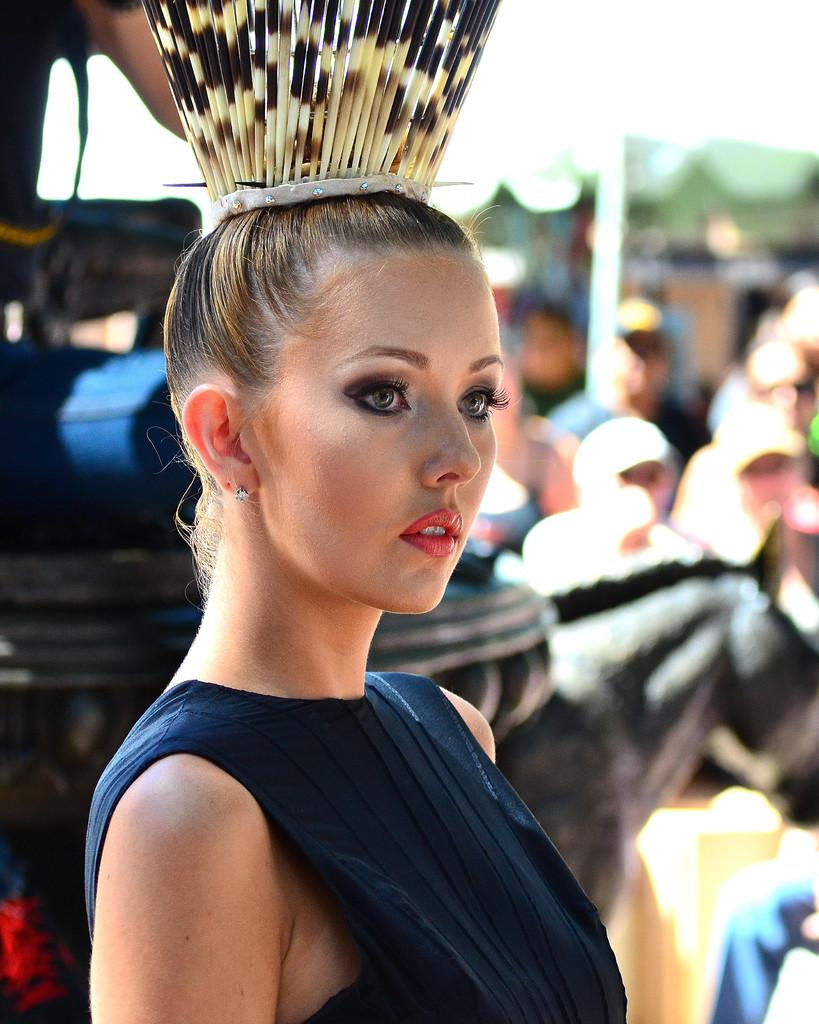What is the woman in the image wearing on her head? The woman is wearing a crown in the image. Can you describe the background of the image? The background of the image is blurred. What can be seen on the right side of the image? There are people and a pole visible on the right side of the image. What type of air can be seen surrounding the woman in the image? There is no air visible in the image; it is a photograph and does not show air. 